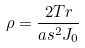Convert formula to latex. <formula><loc_0><loc_0><loc_500><loc_500>\rho = \frac { 2 T r } { a s ^ { 2 } J _ { 0 } }</formula> 